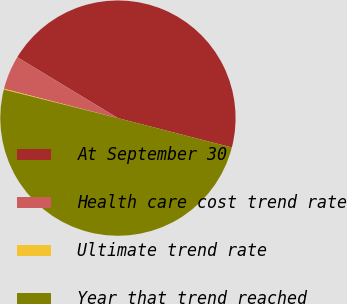Convert chart. <chart><loc_0><loc_0><loc_500><loc_500><pie_chart><fcel>At September 30<fcel>Health care cost trend rate<fcel>Ultimate trend rate<fcel>Year that trend reached<nl><fcel>45.35%<fcel>4.65%<fcel>0.11%<fcel>49.89%<nl></chart> 